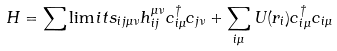Convert formula to latex. <formula><loc_0><loc_0><loc_500><loc_500>H = \sum \lim i t s _ { i j \mu \nu } h _ { i j } ^ { \mu \nu } c _ { i \mu } ^ { \dagger } c _ { j \nu } + \sum _ { i \mu } U ( r _ { i } ) c _ { i \mu } ^ { \dagger } c _ { i \mu }</formula> 